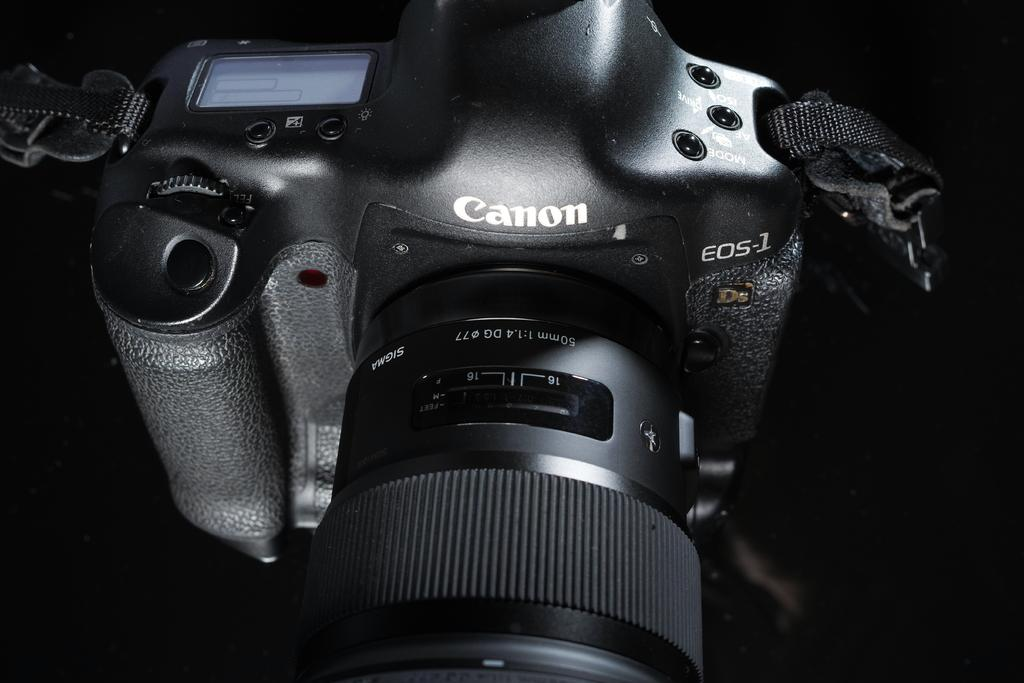What object is placed on the surface in the image? There is a camera on the surface in the image. How many fish can be seen swimming in the image? There are no fish present in the image; it features a camera on a surface. What type of animal is hiding behind the camera in the image? There is no animal present in the image; it only features a camera on a surface. 